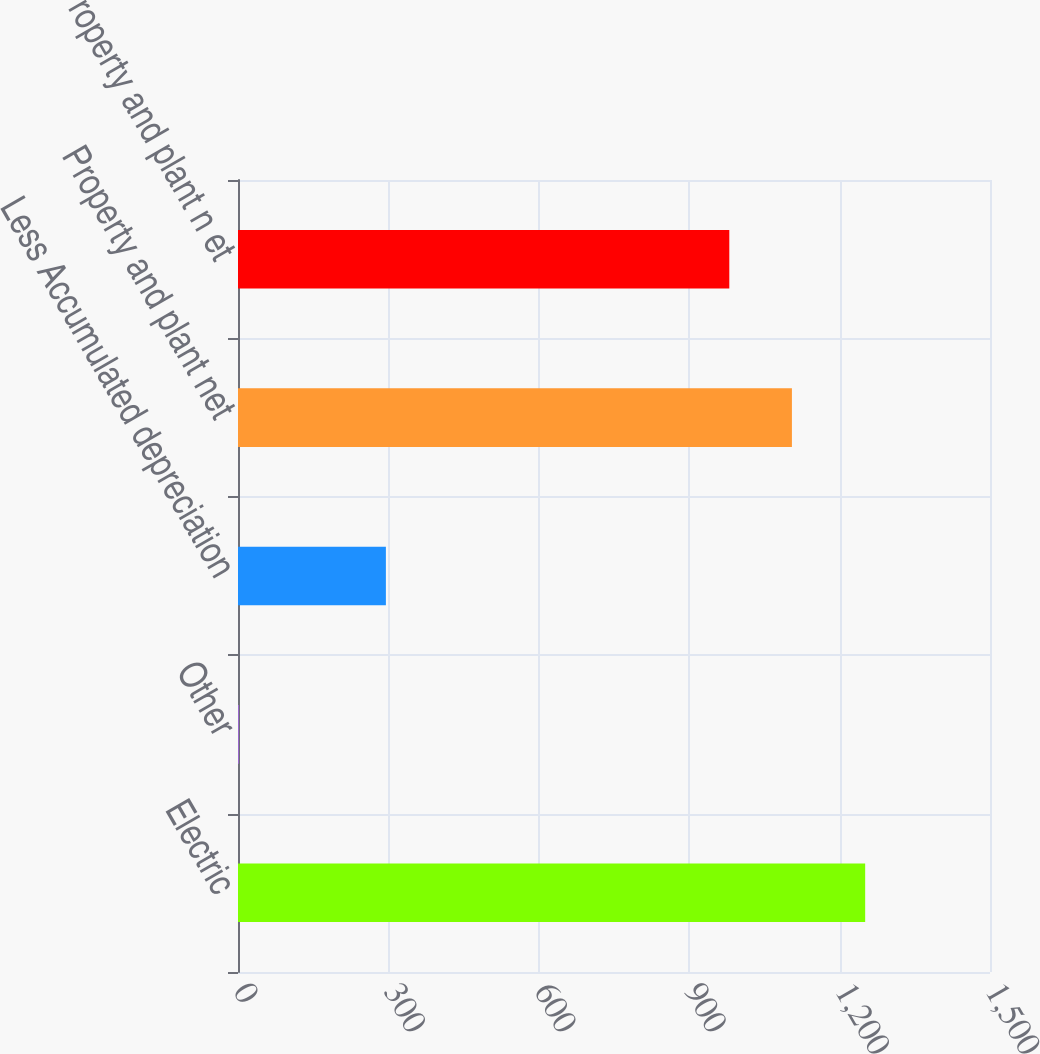Convert chart to OTSL. <chart><loc_0><loc_0><loc_500><loc_500><bar_chart><fcel>Electric<fcel>Other<fcel>Less Accumulated depreciation<fcel>Property and plant net<fcel>Property and plant n et<nl><fcel>1251<fcel>2<fcel>295<fcel>1104.9<fcel>980<nl></chart> 